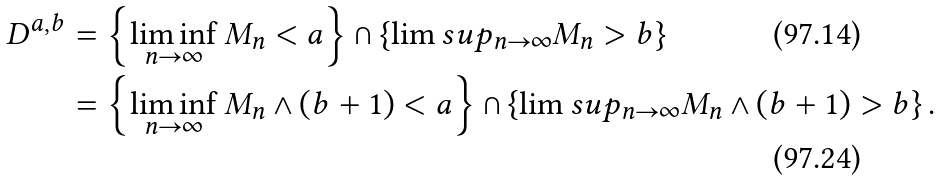Convert formula to latex. <formula><loc_0><loc_0><loc_500><loc_500>D ^ { a , b } & = \left \{ \liminf _ { n \to \infty } M _ { n } < a \right \} \cap \left \{ \lim s u p _ { n \to \infty } M _ { n } > b \right \} \\ & = \left \{ \liminf _ { n \to \infty } M _ { n } \wedge ( b + 1 ) < a \right \} \cap \left \{ \lim s u p _ { n \to \infty } M _ { n } \wedge ( b + 1 ) > b \right \} .</formula> 